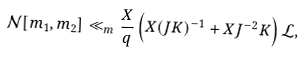Convert formula to latex. <formula><loc_0><loc_0><loc_500><loc_500>\mathcal { N } [ m _ { 1 } , m _ { 2 } ] \ll _ { m } \frac { X } { q } \left ( X ( J K ) ^ { - 1 } + X J ^ { - 2 } K \right ) \mathcal { L } ,</formula> 